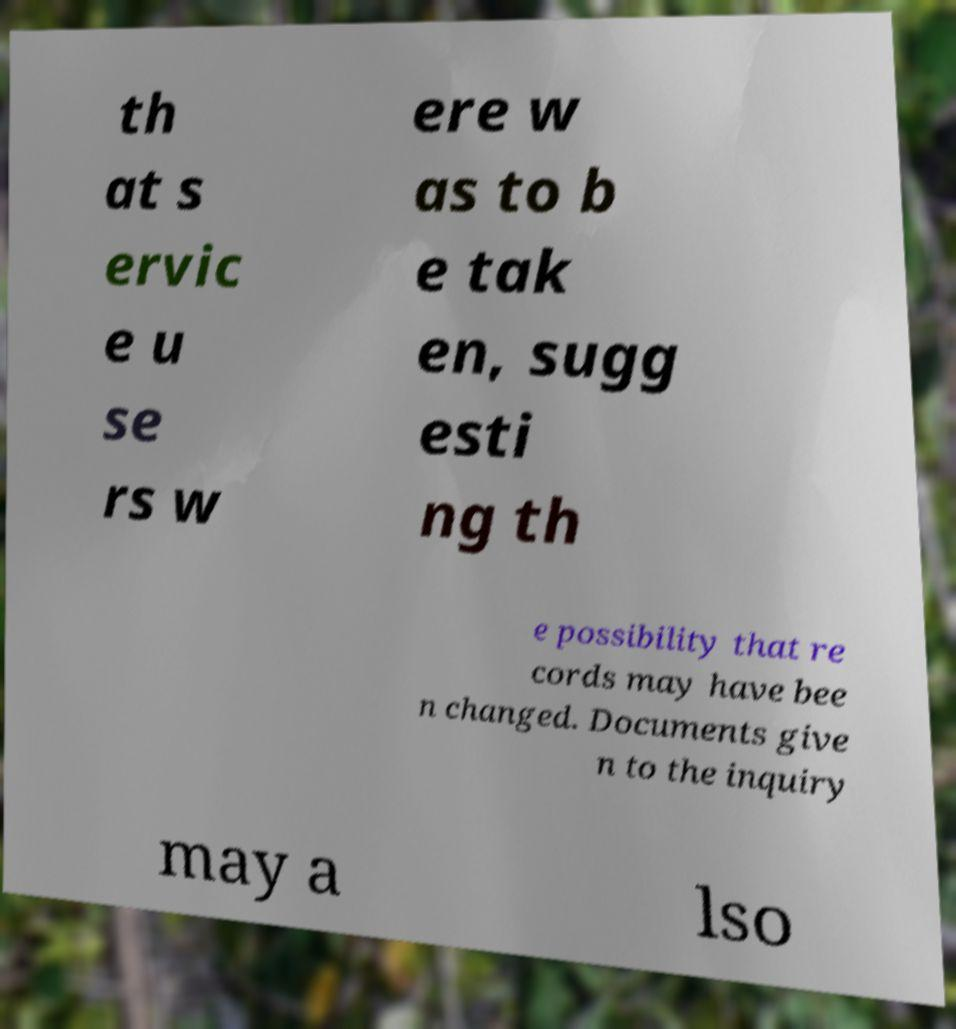For documentation purposes, I need the text within this image transcribed. Could you provide that? th at s ervic e u se rs w ere w as to b e tak en, sugg esti ng th e possibility that re cords may have bee n changed. Documents give n to the inquiry may a lso 